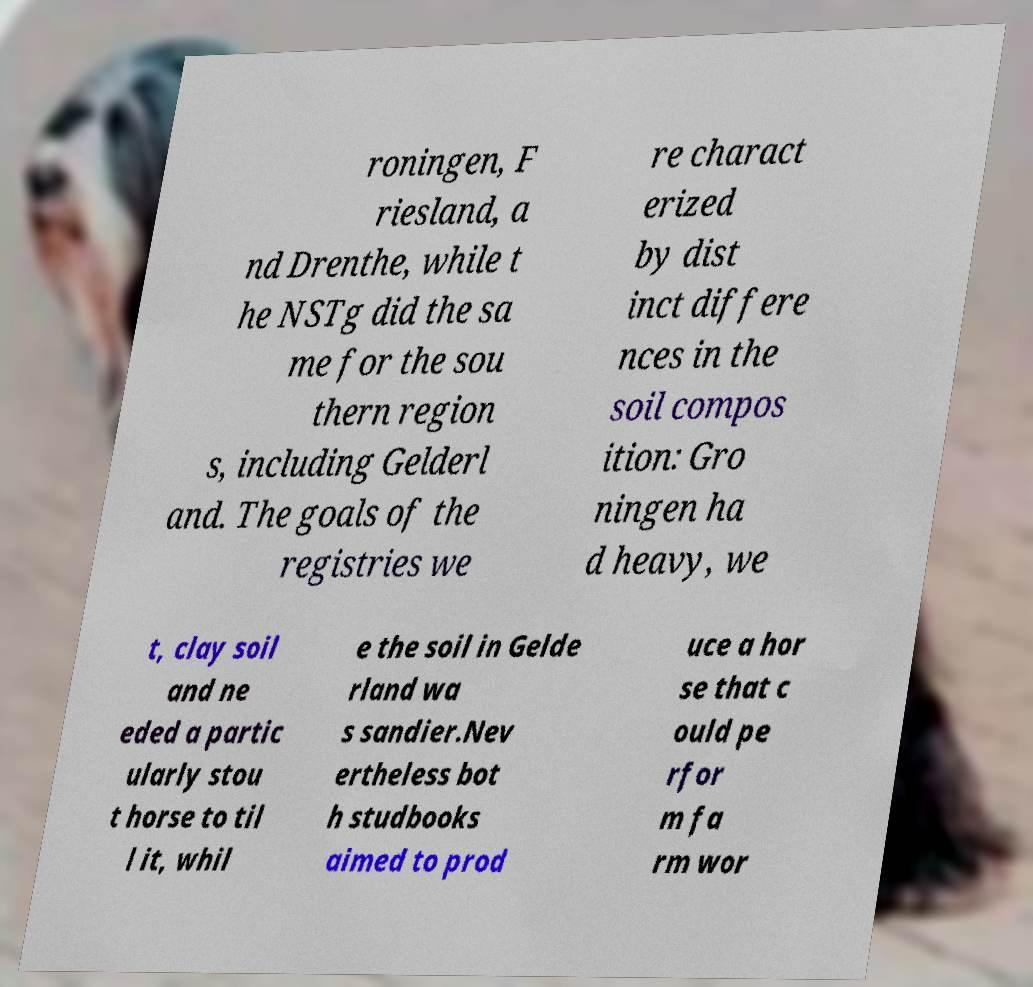Please identify and transcribe the text found in this image. roningen, F riesland, a nd Drenthe, while t he NSTg did the sa me for the sou thern region s, including Gelderl and. The goals of the registries we re charact erized by dist inct differe nces in the soil compos ition: Gro ningen ha d heavy, we t, clay soil and ne eded a partic ularly stou t horse to til l it, whil e the soil in Gelde rland wa s sandier.Nev ertheless bot h studbooks aimed to prod uce a hor se that c ould pe rfor m fa rm wor 